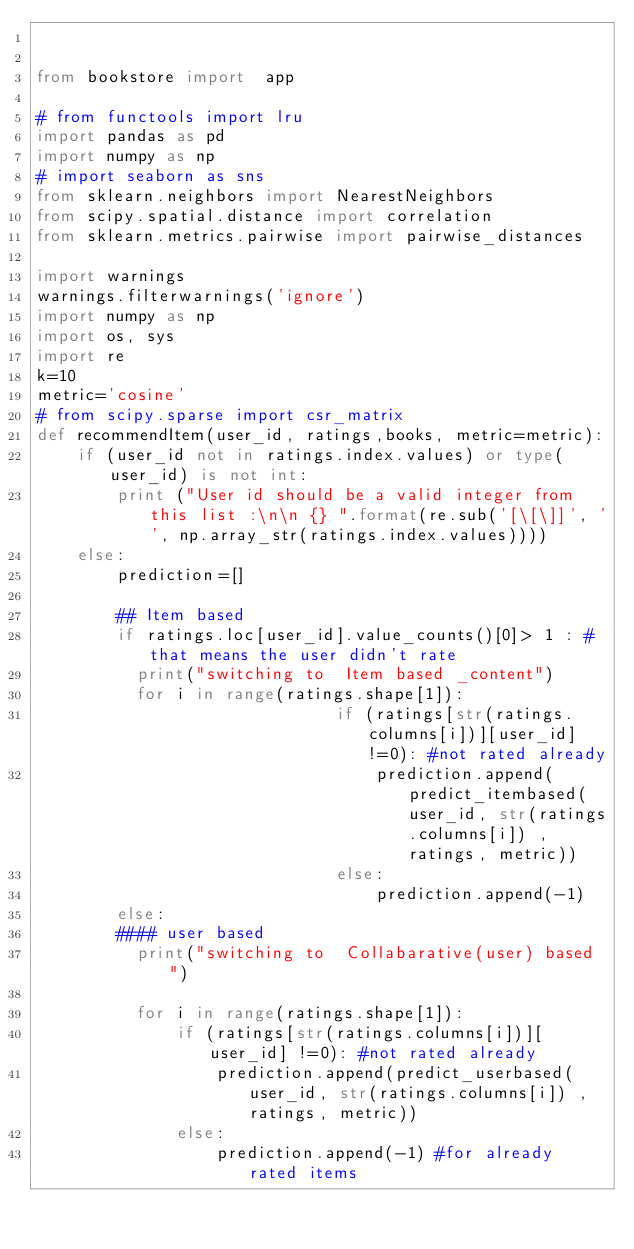Convert code to text. <code><loc_0><loc_0><loc_500><loc_500><_Python_>

from bookstore import  app

# from functools import lru
import pandas as pd
import numpy as np
# import seaborn as sns
from sklearn.neighbors import NearestNeighbors
from scipy.spatial.distance import correlation
from sklearn.metrics.pairwise import pairwise_distances

import warnings
warnings.filterwarnings('ignore')
import numpy as np
import os, sys
import re
k=10
metric='cosine'
# from scipy.sparse import csr_matrix
def recommendItem(user_id, ratings,books, metric=metric):    
    if (user_id not in ratings.index.values) or type(user_id) is not int:
        print ("User id should be a valid integer from this list :\n\n {} ".format(re.sub('[\[\]]', '', np.array_str(ratings.index.values))))
    else:    
        prediction=[]
        
        ## Item based
        if ratings.loc[user_id].value_counts()[0]> 1 : #that means the user didn't rate
          print("switching to  Item based _content")
          for i in range(ratings.shape[1]):
                              if (ratings[str(ratings.columns[i])][user_id] !=0): #not rated already
                                  prediction.append(predict_itembased(user_id, str(ratings.columns[i]) ,ratings, metric))
                              else:                    
                                  prediction.append(-1)
        else:
        #### user based
          print("switching to  Collabarative(user) based ")

          for i in range(ratings.shape[1]):
              if (ratings[str(ratings.columns[i])][user_id] !=0): #not rated already
                  prediction.append(predict_userbased(user_id, str(ratings.columns[i]) ,ratings, metric))
              else:                    
                  prediction.append(-1) #for already rated items</code> 